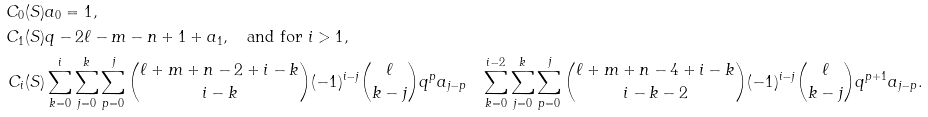<formula> <loc_0><loc_0><loc_500><loc_500>C _ { 0 } ( S ) & a _ { 0 } = 1 , \\ C _ { 1 } ( S ) & q - 2 \ell - m - n + 1 + a _ { 1 } , \quad \text {and for } i > 1 , \\ C _ { i } ( S ) & \sum _ { k = 0 } ^ { i } \sum _ { j = 0 } ^ { k } \sum _ { p = 0 } ^ { j } \binom { \ell + m + n - 2 + i - k } { i - k } ( - 1 ) ^ { i - j } \binom { \ell } { k - j } q ^ { p } a _ { j - p } & \sum _ { k = 0 } ^ { i - 2 } \sum _ { j = 0 } ^ { k } \sum _ { p = 0 } ^ { j } \binom { \ell + m + n - 4 + i - k } { i - k - 2 } ( - 1 ) ^ { i - j } \binom { \ell } { k - j } q ^ { p + 1 } a _ { j - p } .</formula> 